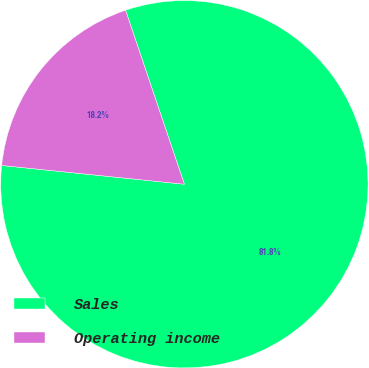<chart> <loc_0><loc_0><loc_500><loc_500><pie_chart><fcel>Sales<fcel>Operating income<nl><fcel>81.82%<fcel>18.18%<nl></chart> 